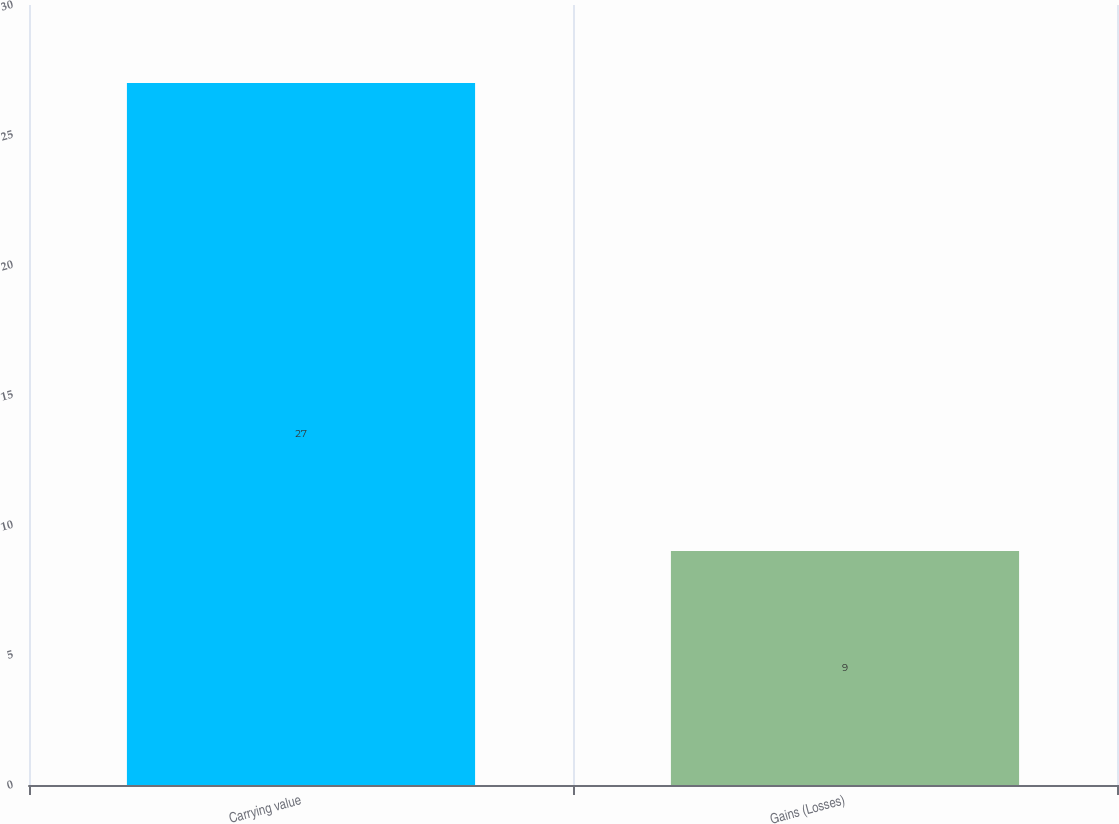<chart> <loc_0><loc_0><loc_500><loc_500><bar_chart><fcel>Carrying value<fcel>Gains (Losses)<nl><fcel>27<fcel>9<nl></chart> 